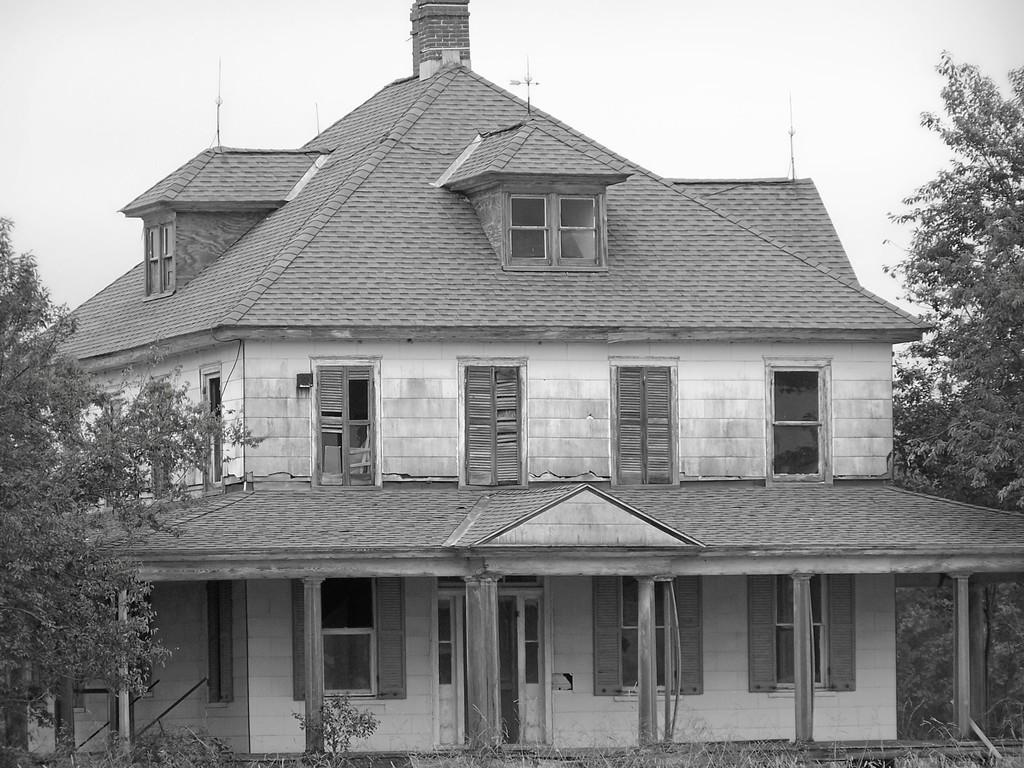What is the color scheme of the image? The image is black and white. What can be seen in the center of the image? There is a sky in the center of the image. What is visible in the sky? Clouds are visible in the image. What type of natural elements can be seen in the image? Trees and plants are present in the image. Can any structures be identified in the image? Yes, there is at least one building, pillars, windows, a door, and fences visible in the image. Are there any other objects in the image? Yes, there are a few other objects in the image. What type of hair can be seen on the tray in the image? There is no tray or hair present in the image. 